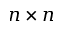Convert formula to latex. <formula><loc_0><loc_0><loc_500><loc_500>n \times n</formula> 